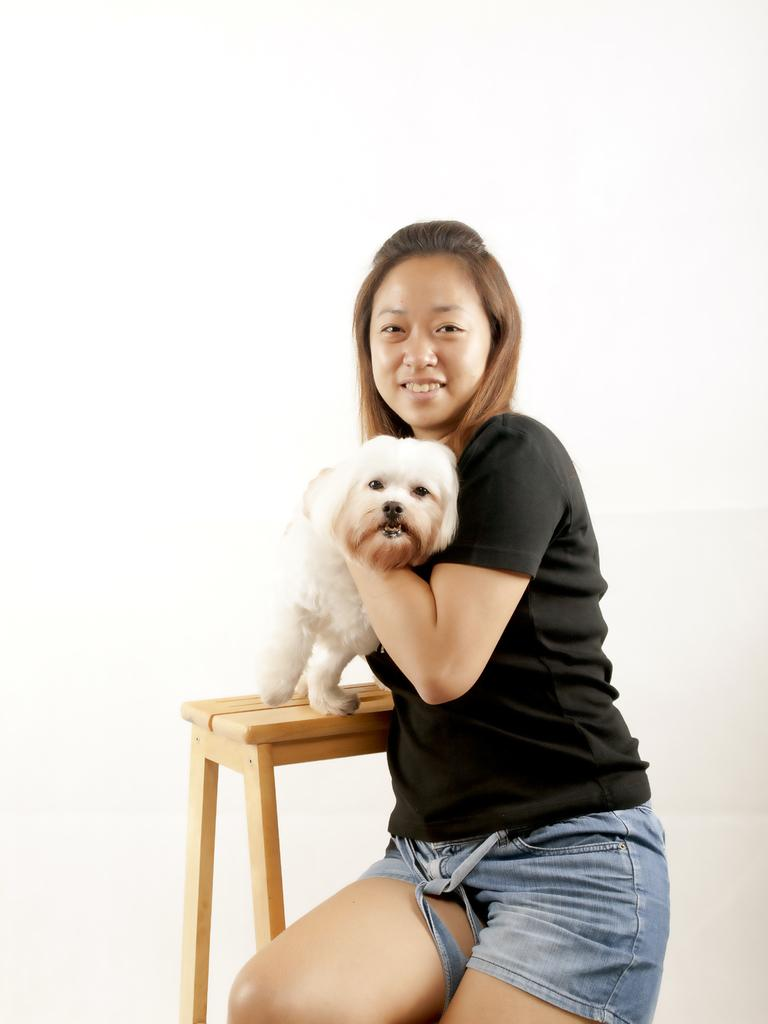Who is the main subject in the image? There is a woman in the image. What is the woman wearing? The woman is wearing a black dress. What is the woman holding in the image? The woman is holding a dog. Where is the dog positioned in the image? The dog is on a stool. What type of playground equipment can be seen in the image? There is no playground equipment present in the image. What condition is the hammer in within the image? There is no hammer present in the image. 